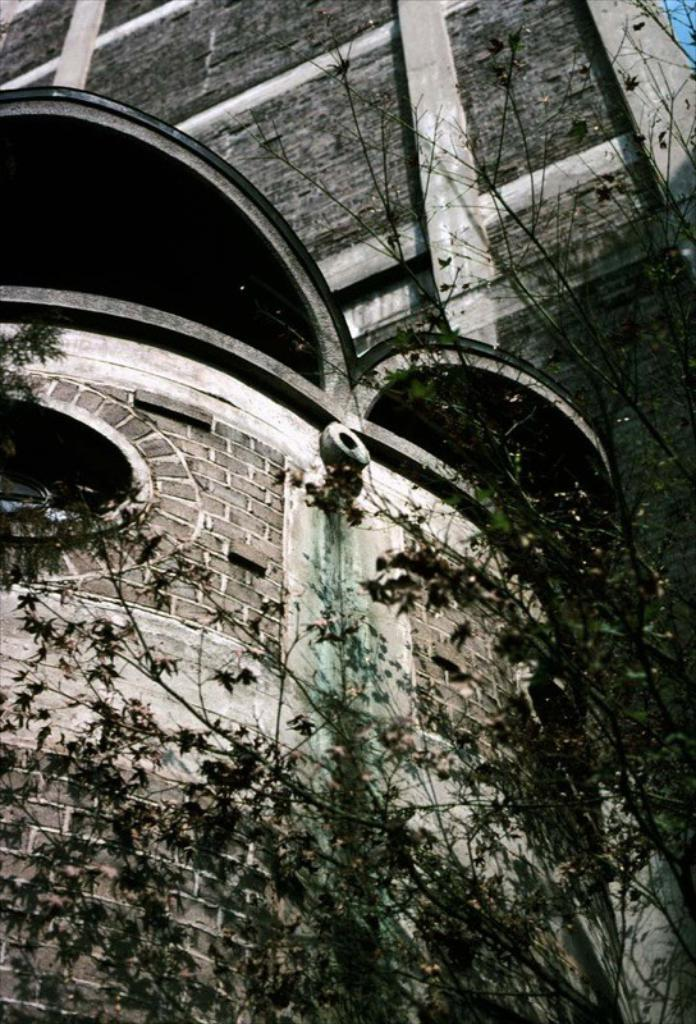What is the color scheme of the image? The image is black and white. What type of natural element can be seen in the image? There is a tree in the image. What type of structure is visible in the background of the image? There is a big building in the background of the image. What type of lumber is being used to construct the tree in the image? There is no construction or lumber involved in the tree, as it is a natural element. 